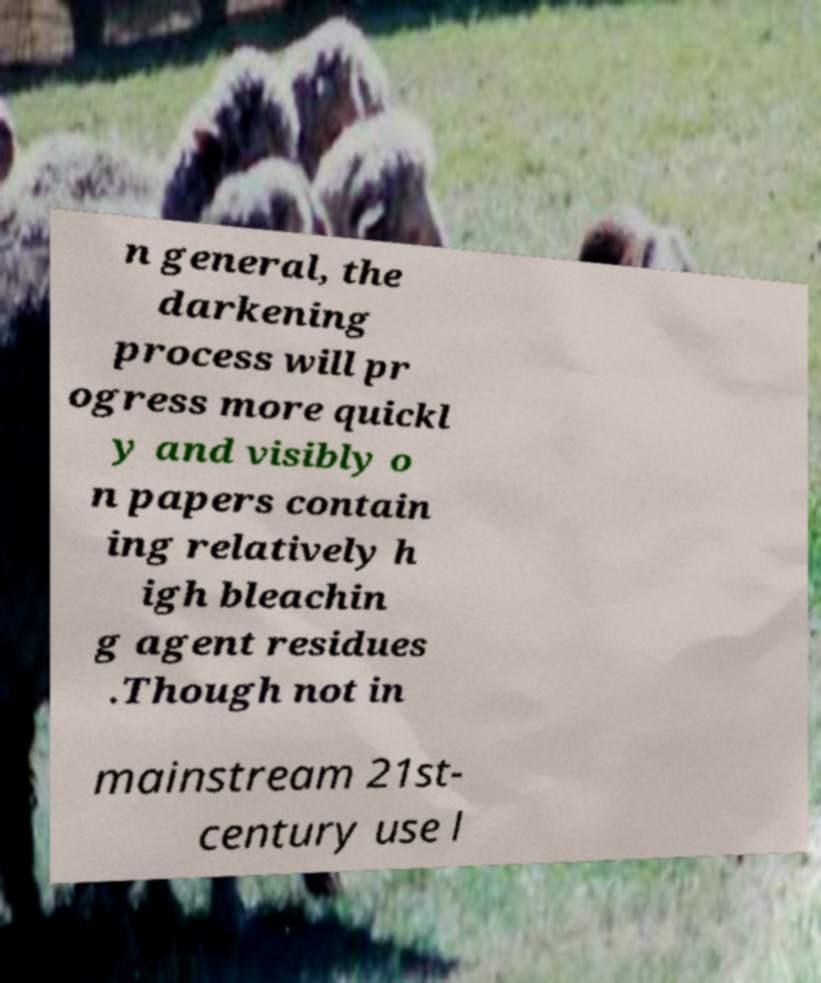Could you extract and type out the text from this image? n general, the darkening process will pr ogress more quickl y and visibly o n papers contain ing relatively h igh bleachin g agent residues .Though not in mainstream 21st- century use l 